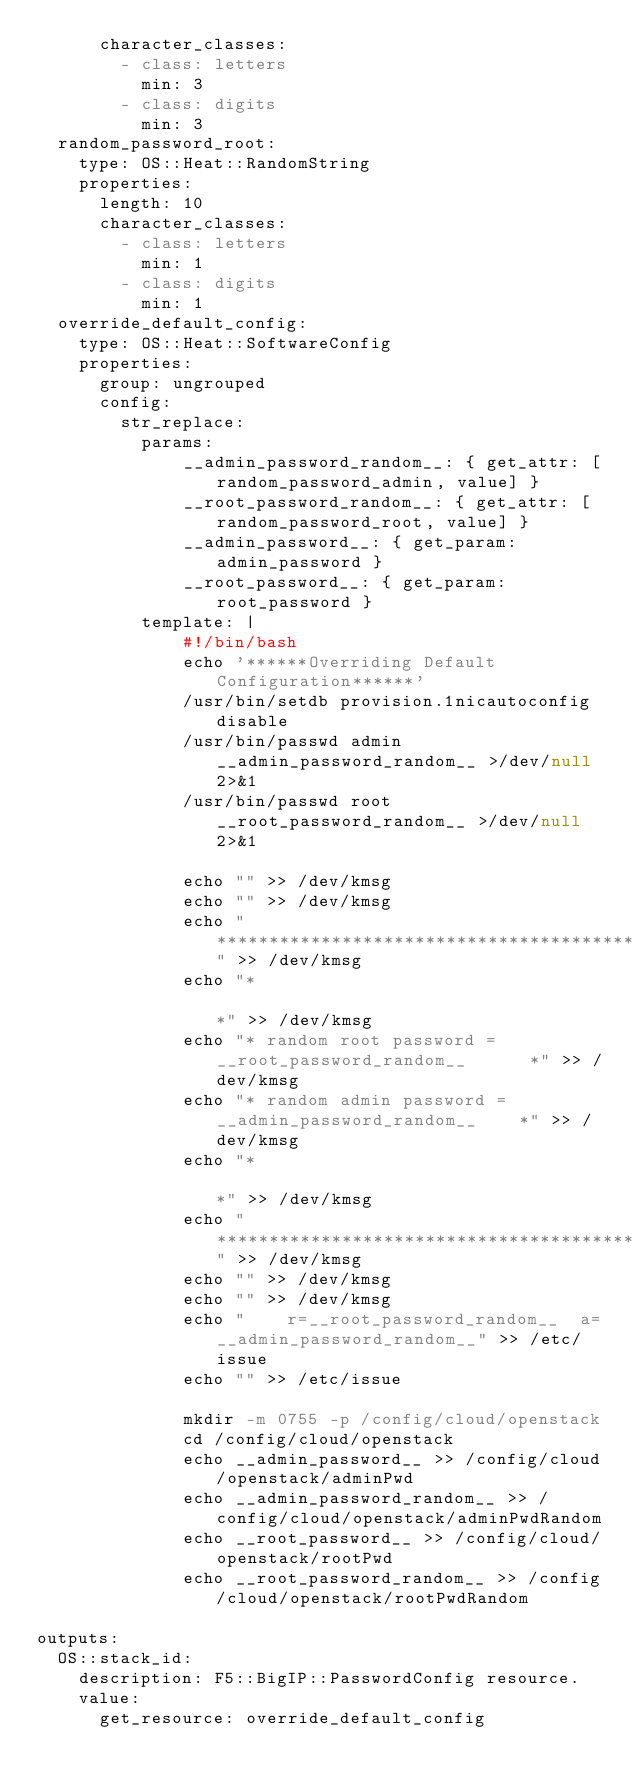Convert code to text. <code><loc_0><loc_0><loc_500><loc_500><_YAML_>      character_classes:
        - class: letters
          min: 3
        - class: digits
          min: 3
  random_password_root:
    type: OS::Heat::RandomString
    properties:
      length: 10
      character_classes:
        - class: letters
          min: 1
        - class: digits
          min: 1
  override_default_config:
    type: OS::Heat::SoftwareConfig
    properties:
      group: ungrouped
      config: 
        str_replace:
          params:
              __admin_password_random__: { get_attr: [random_password_admin, value] }
              __root_password_random__: { get_attr: [random_password_root, value] }
              __admin_password__: { get_param: admin_password }
              __root_password__: { get_param: root_password }
          template: |
              #!/bin/bash
              echo '******Overriding Default Configuration******'
              /usr/bin/setdb provision.1nicautoconfig disable
              /usr/bin/passwd admin __admin_password_random__ >/dev/null 2>&1
              /usr/bin/passwd root __root_password_random__ >/dev/null 2>&1

              echo "" >> /dev/kmsg
              echo "" >> /dev/kmsg
              echo "********************************************************" >> /dev/kmsg
              echo "*                                                      *" >> /dev/kmsg
              echo "* random root password = __root_password_random__      *" >> /dev/kmsg
              echo "* random admin password = __admin_password_random__    *" >> /dev/kmsg
              echo "*                                                      *" >> /dev/kmsg
              echo "********************************************************" >> /dev/kmsg
              echo "" >> /dev/kmsg
              echo "" >> /dev/kmsg
              echo "    r=__root_password_random__  a=__admin_password_random__" >> /etc/issue
              echo "" >> /etc/issue

              mkdir -m 0755 -p /config/cloud/openstack
              cd /config/cloud/openstack
              echo __admin_password__ >> /config/cloud/openstack/adminPwd
              echo __admin_password_random__ >> /config/cloud/openstack/adminPwdRandom
              echo __root_password__ >> /config/cloud/openstack/rootPwd
              echo __root_password_random__ >> /config/cloud/openstack/rootPwdRandom

outputs:
  OS::stack_id:
    description: F5::BigIP::PasswordConfig resource.
    value:
      get_resource: override_default_config</code> 